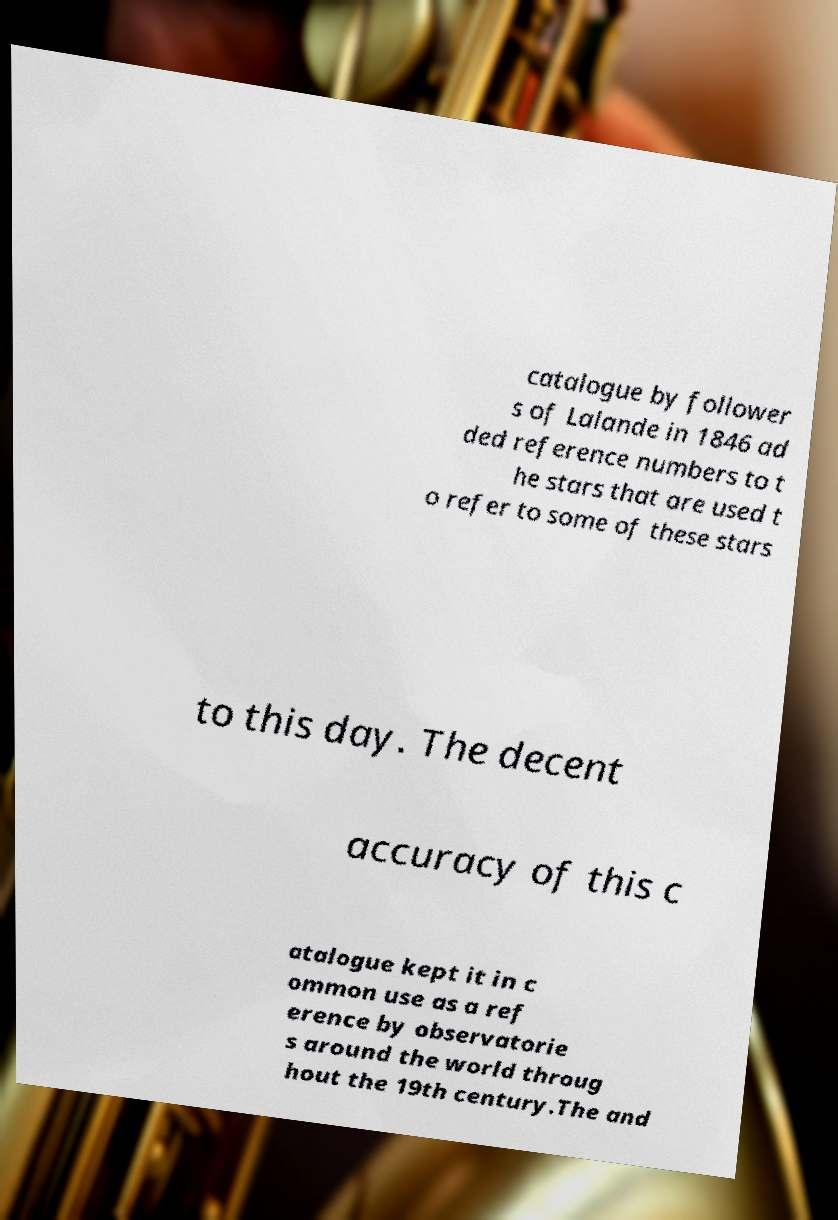I need the written content from this picture converted into text. Can you do that? catalogue by follower s of Lalande in 1846 ad ded reference numbers to t he stars that are used t o refer to some of these stars to this day. The decent accuracy of this c atalogue kept it in c ommon use as a ref erence by observatorie s around the world throug hout the 19th century.The and 